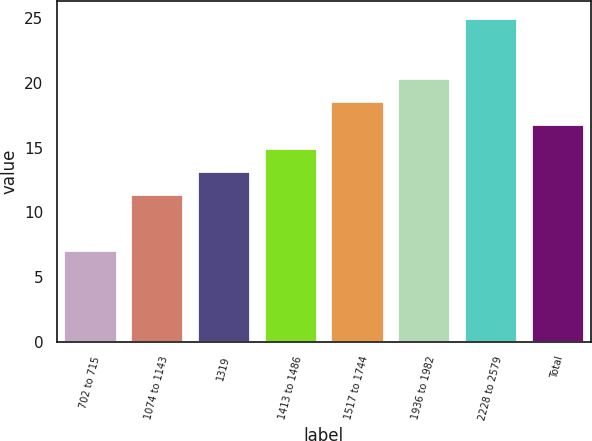<chart> <loc_0><loc_0><loc_500><loc_500><bar_chart><fcel>702 to 715<fcel>1074 to 1143<fcel>1319<fcel>1413 to 1486<fcel>1517 to 1744<fcel>1936 to 1982<fcel>2228 to 2579<fcel>Total<nl><fcel>7.14<fcel>11.42<fcel>13.21<fcel>15<fcel>18.58<fcel>20.37<fcel>25.03<fcel>16.79<nl></chart> 